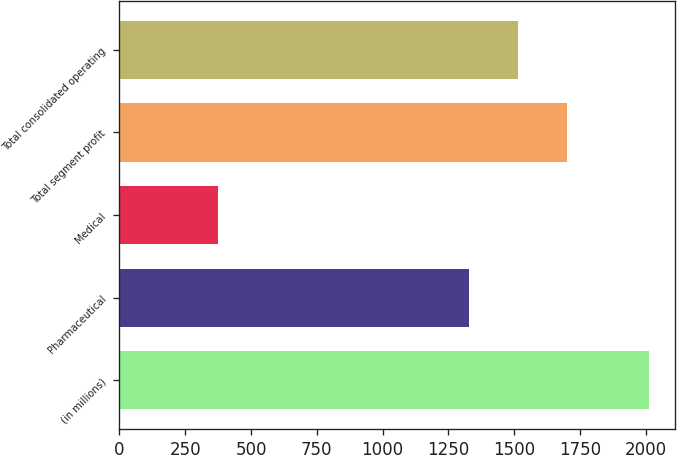Convert chart. <chart><loc_0><loc_0><loc_500><loc_500><bar_chart><fcel>(in millions)<fcel>Pharmaceutical<fcel>Medical<fcel>Total segment profit<fcel>Total consolidated operating<nl><fcel>2011<fcel>1329<fcel>373<fcel>1702<fcel>1514<nl></chart> 